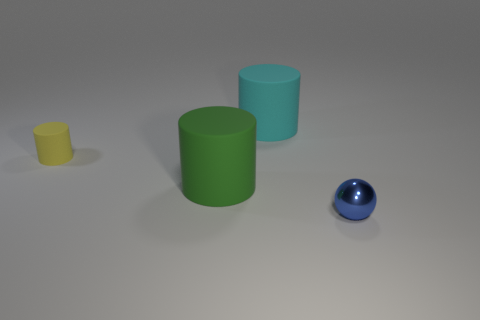Are there fewer tiny cyan metallic spheres than tiny spheres?
Offer a very short reply. Yes. There is a thing that is both behind the large green rubber object and to the left of the large cyan matte thing; what material is it?
Your answer should be compact. Rubber. Are there any small cylinders that are behind the rubber cylinder that is on the right side of the large green thing?
Keep it short and to the point. No. What number of things are tiny blue matte cylinders or yellow rubber cylinders?
Offer a terse response. 1. There is a matte thing that is both behind the large green cylinder and left of the large cyan object; what is its shape?
Provide a short and direct response. Cylinder. Are the large object in front of the yellow cylinder and the cyan object made of the same material?
Your response must be concise. Yes. How many objects are matte cylinders or cylinders behind the small cylinder?
Offer a terse response. 3. What color is the other tiny thing that is the same material as the green thing?
Your answer should be compact. Yellow. How many small yellow objects have the same material as the small blue sphere?
Make the answer very short. 0. What number of small red matte objects are there?
Your response must be concise. 0. 